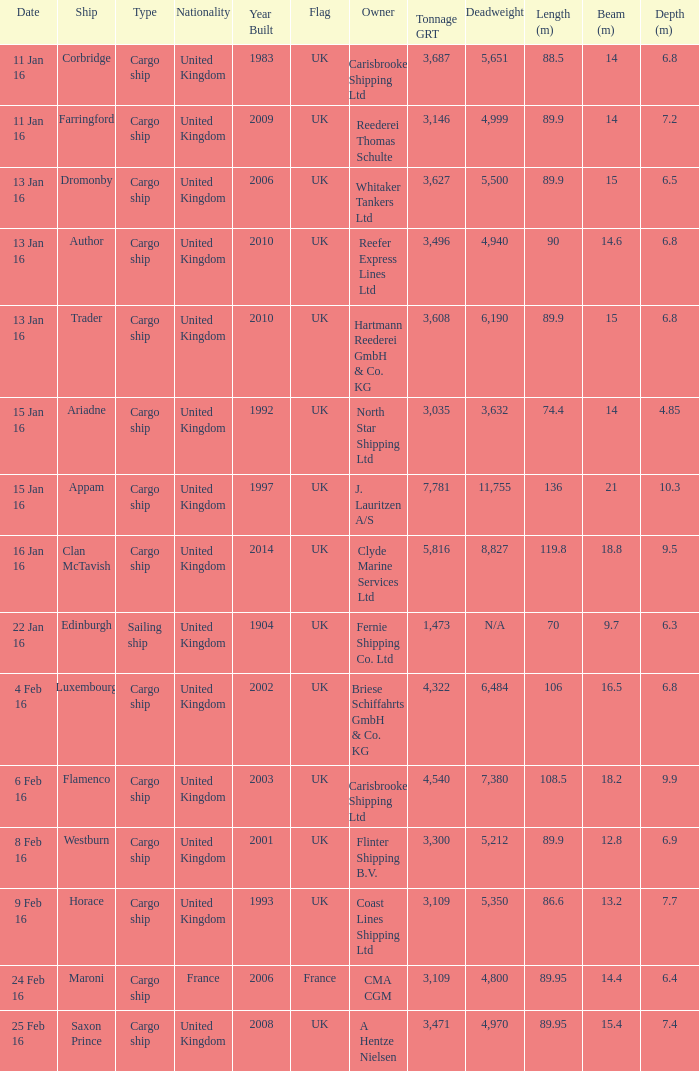What is the tonnage grt of the ship author? 3496.0. 